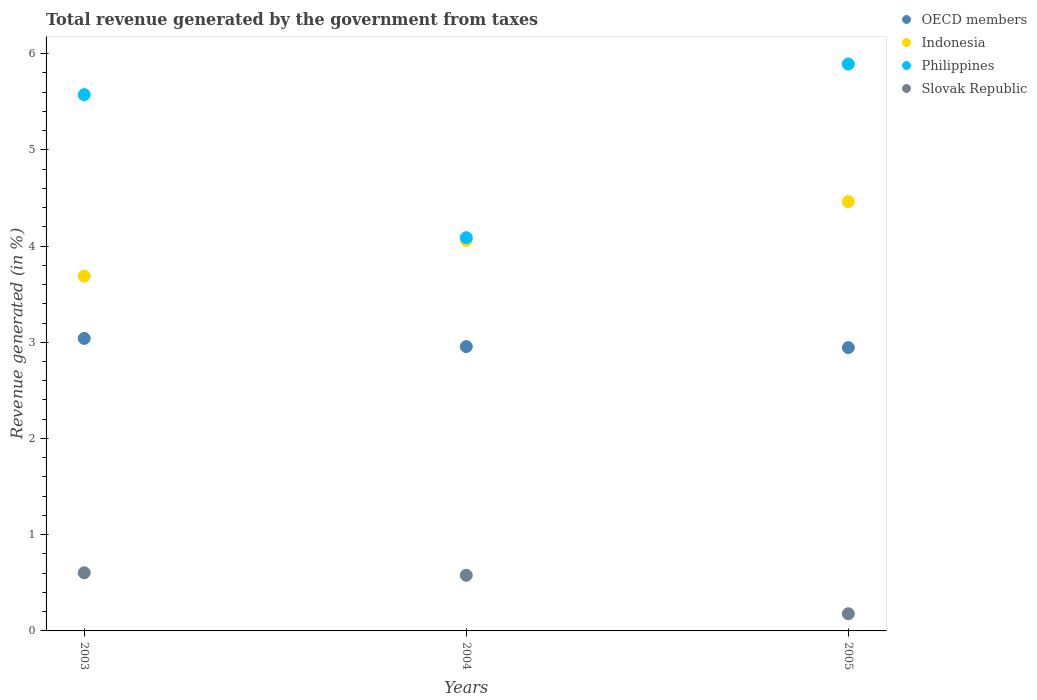What is the total revenue generated in Slovak Republic in 2003?
Keep it short and to the point. 0.6. Across all years, what is the maximum total revenue generated in Philippines?
Your answer should be compact. 5.89. Across all years, what is the minimum total revenue generated in Slovak Republic?
Your response must be concise. 0.18. What is the total total revenue generated in OECD members in the graph?
Give a very brief answer. 8.94. What is the difference between the total revenue generated in OECD members in 2003 and that in 2004?
Your answer should be very brief. 0.09. What is the difference between the total revenue generated in Philippines in 2004 and the total revenue generated in Indonesia in 2003?
Keep it short and to the point. 0.4. What is the average total revenue generated in OECD members per year?
Provide a short and direct response. 2.98. In the year 2004, what is the difference between the total revenue generated in Indonesia and total revenue generated in Philippines?
Offer a terse response. -0.03. What is the ratio of the total revenue generated in OECD members in 2003 to that in 2004?
Your response must be concise. 1.03. Is the total revenue generated in Indonesia in 2004 less than that in 2005?
Your answer should be very brief. Yes. What is the difference between the highest and the second highest total revenue generated in Indonesia?
Offer a terse response. 0.4. What is the difference between the highest and the lowest total revenue generated in Slovak Republic?
Your answer should be compact. 0.43. Is it the case that in every year, the sum of the total revenue generated in Indonesia and total revenue generated in OECD members  is greater than the sum of total revenue generated in Slovak Republic and total revenue generated in Philippines?
Offer a very short reply. No. Is it the case that in every year, the sum of the total revenue generated in Indonesia and total revenue generated in Slovak Republic  is greater than the total revenue generated in Philippines?
Your answer should be compact. No. Is the total revenue generated in OECD members strictly greater than the total revenue generated in Indonesia over the years?
Offer a very short reply. No. How many years are there in the graph?
Make the answer very short. 3. How many legend labels are there?
Make the answer very short. 4. How are the legend labels stacked?
Keep it short and to the point. Vertical. What is the title of the graph?
Offer a terse response. Total revenue generated by the government from taxes. Does "St. Martin (French part)" appear as one of the legend labels in the graph?
Provide a succinct answer. No. What is the label or title of the X-axis?
Give a very brief answer. Years. What is the label or title of the Y-axis?
Your answer should be very brief. Revenue generated (in %). What is the Revenue generated (in %) of OECD members in 2003?
Offer a very short reply. 3.04. What is the Revenue generated (in %) of Indonesia in 2003?
Make the answer very short. 3.69. What is the Revenue generated (in %) of Philippines in 2003?
Provide a succinct answer. 5.57. What is the Revenue generated (in %) in Slovak Republic in 2003?
Offer a very short reply. 0.6. What is the Revenue generated (in %) of OECD members in 2004?
Offer a terse response. 2.95. What is the Revenue generated (in %) of Indonesia in 2004?
Your answer should be very brief. 4.06. What is the Revenue generated (in %) of Philippines in 2004?
Ensure brevity in your answer.  4.09. What is the Revenue generated (in %) in Slovak Republic in 2004?
Provide a short and direct response. 0.58. What is the Revenue generated (in %) of OECD members in 2005?
Keep it short and to the point. 2.94. What is the Revenue generated (in %) of Indonesia in 2005?
Your response must be concise. 4.46. What is the Revenue generated (in %) in Philippines in 2005?
Make the answer very short. 5.89. What is the Revenue generated (in %) of Slovak Republic in 2005?
Your answer should be very brief. 0.18. Across all years, what is the maximum Revenue generated (in %) of OECD members?
Provide a short and direct response. 3.04. Across all years, what is the maximum Revenue generated (in %) of Indonesia?
Provide a short and direct response. 4.46. Across all years, what is the maximum Revenue generated (in %) of Philippines?
Provide a short and direct response. 5.89. Across all years, what is the maximum Revenue generated (in %) of Slovak Republic?
Your response must be concise. 0.6. Across all years, what is the minimum Revenue generated (in %) of OECD members?
Keep it short and to the point. 2.94. Across all years, what is the minimum Revenue generated (in %) in Indonesia?
Give a very brief answer. 3.69. Across all years, what is the minimum Revenue generated (in %) in Philippines?
Give a very brief answer. 4.09. Across all years, what is the minimum Revenue generated (in %) of Slovak Republic?
Provide a short and direct response. 0.18. What is the total Revenue generated (in %) of OECD members in the graph?
Provide a short and direct response. 8.94. What is the total Revenue generated (in %) of Indonesia in the graph?
Make the answer very short. 12.21. What is the total Revenue generated (in %) of Philippines in the graph?
Your answer should be very brief. 15.55. What is the total Revenue generated (in %) in Slovak Republic in the graph?
Provide a short and direct response. 1.36. What is the difference between the Revenue generated (in %) of OECD members in 2003 and that in 2004?
Provide a succinct answer. 0.09. What is the difference between the Revenue generated (in %) of Indonesia in 2003 and that in 2004?
Offer a very short reply. -0.37. What is the difference between the Revenue generated (in %) in Philippines in 2003 and that in 2004?
Provide a short and direct response. 1.49. What is the difference between the Revenue generated (in %) in Slovak Republic in 2003 and that in 2004?
Provide a succinct answer. 0.03. What is the difference between the Revenue generated (in %) in OECD members in 2003 and that in 2005?
Make the answer very short. 0.1. What is the difference between the Revenue generated (in %) in Indonesia in 2003 and that in 2005?
Make the answer very short. -0.77. What is the difference between the Revenue generated (in %) of Philippines in 2003 and that in 2005?
Offer a very short reply. -0.32. What is the difference between the Revenue generated (in %) of Slovak Republic in 2003 and that in 2005?
Provide a succinct answer. 0.43. What is the difference between the Revenue generated (in %) of OECD members in 2004 and that in 2005?
Give a very brief answer. 0.01. What is the difference between the Revenue generated (in %) in Indonesia in 2004 and that in 2005?
Your answer should be compact. -0.4. What is the difference between the Revenue generated (in %) in Philippines in 2004 and that in 2005?
Offer a terse response. -1.8. What is the difference between the Revenue generated (in %) in Slovak Republic in 2004 and that in 2005?
Give a very brief answer. 0.4. What is the difference between the Revenue generated (in %) in OECD members in 2003 and the Revenue generated (in %) in Indonesia in 2004?
Provide a short and direct response. -1.02. What is the difference between the Revenue generated (in %) in OECD members in 2003 and the Revenue generated (in %) in Philippines in 2004?
Provide a succinct answer. -1.05. What is the difference between the Revenue generated (in %) of OECD members in 2003 and the Revenue generated (in %) of Slovak Republic in 2004?
Offer a terse response. 2.46. What is the difference between the Revenue generated (in %) in Indonesia in 2003 and the Revenue generated (in %) in Philippines in 2004?
Provide a short and direct response. -0.4. What is the difference between the Revenue generated (in %) in Indonesia in 2003 and the Revenue generated (in %) in Slovak Republic in 2004?
Provide a succinct answer. 3.11. What is the difference between the Revenue generated (in %) in Philippines in 2003 and the Revenue generated (in %) in Slovak Republic in 2004?
Keep it short and to the point. 5. What is the difference between the Revenue generated (in %) of OECD members in 2003 and the Revenue generated (in %) of Indonesia in 2005?
Offer a very short reply. -1.42. What is the difference between the Revenue generated (in %) in OECD members in 2003 and the Revenue generated (in %) in Philippines in 2005?
Keep it short and to the point. -2.85. What is the difference between the Revenue generated (in %) of OECD members in 2003 and the Revenue generated (in %) of Slovak Republic in 2005?
Give a very brief answer. 2.86. What is the difference between the Revenue generated (in %) in Indonesia in 2003 and the Revenue generated (in %) in Philippines in 2005?
Make the answer very short. -2.2. What is the difference between the Revenue generated (in %) of Indonesia in 2003 and the Revenue generated (in %) of Slovak Republic in 2005?
Provide a short and direct response. 3.51. What is the difference between the Revenue generated (in %) of Philippines in 2003 and the Revenue generated (in %) of Slovak Republic in 2005?
Ensure brevity in your answer.  5.39. What is the difference between the Revenue generated (in %) in OECD members in 2004 and the Revenue generated (in %) in Indonesia in 2005?
Offer a terse response. -1.51. What is the difference between the Revenue generated (in %) of OECD members in 2004 and the Revenue generated (in %) of Philippines in 2005?
Provide a short and direct response. -2.94. What is the difference between the Revenue generated (in %) in OECD members in 2004 and the Revenue generated (in %) in Slovak Republic in 2005?
Offer a very short reply. 2.78. What is the difference between the Revenue generated (in %) in Indonesia in 2004 and the Revenue generated (in %) in Philippines in 2005?
Give a very brief answer. -1.83. What is the difference between the Revenue generated (in %) of Indonesia in 2004 and the Revenue generated (in %) of Slovak Republic in 2005?
Keep it short and to the point. 3.88. What is the difference between the Revenue generated (in %) of Philippines in 2004 and the Revenue generated (in %) of Slovak Republic in 2005?
Ensure brevity in your answer.  3.91. What is the average Revenue generated (in %) in OECD members per year?
Offer a very short reply. 2.98. What is the average Revenue generated (in %) in Indonesia per year?
Provide a short and direct response. 4.07. What is the average Revenue generated (in %) in Philippines per year?
Provide a succinct answer. 5.18. What is the average Revenue generated (in %) of Slovak Republic per year?
Make the answer very short. 0.45. In the year 2003, what is the difference between the Revenue generated (in %) in OECD members and Revenue generated (in %) in Indonesia?
Offer a very short reply. -0.65. In the year 2003, what is the difference between the Revenue generated (in %) in OECD members and Revenue generated (in %) in Philippines?
Your answer should be compact. -2.53. In the year 2003, what is the difference between the Revenue generated (in %) in OECD members and Revenue generated (in %) in Slovak Republic?
Your answer should be compact. 2.44. In the year 2003, what is the difference between the Revenue generated (in %) in Indonesia and Revenue generated (in %) in Philippines?
Offer a very short reply. -1.89. In the year 2003, what is the difference between the Revenue generated (in %) in Indonesia and Revenue generated (in %) in Slovak Republic?
Offer a very short reply. 3.08. In the year 2003, what is the difference between the Revenue generated (in %) of Philippines and Revenue generated (in %) of Slovak Republic?
Provide a short and direct response. 4.97. In the year 2004, what is the difference between the Revenue generated (in %) of OECD members and Revenue generated (in %) of Indonesia?
Keep it short and to the point. -1.1. In the year 2004, what is the difference between the Revenue generated (in %) of OECD members and Revenue generated (in %) of Philippines?
Keep it short and to the point. -1.13. In the year 2004, what is the difference between the Revenue generated (in %) of OECD members and Revenue generated (in %) of Slovak Republic?
Offer a very short reply. 2.38. In the year 2004, what is the difference between the Revenue generated (in %) in Indonesia and Revenue generated (in %) in Philippines?
Provide a succinct answer. -0.03. In the year 2004, what is the difference between the Revenue generated (in %) of Indonesia and Revenue generated (in %) of Slovak Republic?
Offer a very short reply. 3.48. In the year 2004, what is the difference between the Revenue generated (in %) of Philippines and Revenue generated (in %) of Slovak Republic?
Make the answer very short. 3.51. In the year 2005, what is the difference between the Revenue generated (in %) of OECD members and Revenue generated (in %) of Indonesia?
Make the answer very short. -1.52. In the year 2005, what is the difference between the Revenue generated (in %) of OECD members and Revenue generated (in %) of Philippines?
Offer a terse response. -2.95. In the year 2005, what is the difference between the Revenue generated (in %) of OECD members and Revenue generated (in %) of Slovak Republic?
Keep it short and to the point. 2.77. In the year 2005, what is the difference between the Revenue generated (in %) of Indonesia and Revenue generated (in %) of Philippines?
Your answer should be very brief. -1.43. In the year 2005, what is the difference between the Revenue generated (in %) in Indonesia and Revenue generated (in %) in Slovak Republic?
Your answer should be very brief. 4.28. In the year 2005, what is the difference between the Revenue generated (in %) of Philippines and Revenue generated (in %) of Slovak Republic?
Make the answer very short. 5.71. What is the ratio of the Revenue generated (in %) of OECD members in 2003 to that in 2004?
Provide a short and direct response. 1.03. What is the ratio of the Revenue generated (in %) in Indonesia in 2003 to that in 2004?
Your answer should be compact. 0.91. What is the ratio of the Revenue generated (in %) of Philippines in 2003 to that in 2004?
Give a very brief answer. 1.36. What is the ratio of the Revenue generated (in %) in Slovak Republic in 2003 to that in 2004?
Keep it short and to the point. 1.05. What is the ratio of the Revenue generated (in %) of OECD members in 2003 to that in 2005?
Keep it short and to the point. 1.03. What is the ratio of the Revenue generated (in %) in Indonesia in 2003 to that in 2005?
Make the answer very short. 0.83. What is the ratio of the Revenue generated (in %) in Philippines in 2003 to that in 2005?
Your answer should be compact. 0.95. What is the ratio of the Revenue generated (in %) in Slovak Republic in 2003 to that in 2005?
Make the answer very short. 3.38. What is the ratio of the Revenue generated (in %) in Indonesia in 2004 to that in 2005?
Offer a terse response. 0.91. What is the ratio of the Revenue generated (in %) of Philippines in 2004 to that in 2005?
Give a very brief answer. 0.69. What is the ratio of the Revenue generated (in %) of Slovak Republic in 2004 to that in 2005?
Provide a succinct answer. 3.23. What is the difference between the highest and the second highest Revenue generated (in %) in OECD members?
Provide a succinct answer. 0.09. What is the difference between the highest and the second highest Revenue generated (in %) in Indonesia?
Your response must be concise. 0.4. What is the difference between the highest and the second highest Revenue generated (in %) in Philippines?
Offer a terse response. 0.32. What is the difference between the highest and the second highest Revenue generated (in %) in Slovak Republic?
Offer a terse response. 0.03. What is the difference between the highest and the lowest Revenue generated (in %) of OECD members?
Provide a short and direct response. 0.1. What is the difference between the highest and the lowest Revenue generated (in %) in Indonesia?
Keep it short and to the point. 0.77. What is the difference between the highest and the lowest Revenue generated (in %) of Philippines?
Your answer should be very brief. 1.8. What is the difference between the highest and the lowest Revenue generated (in %) in Slovak Republic?
Provide a succinct answer. 0.43. 